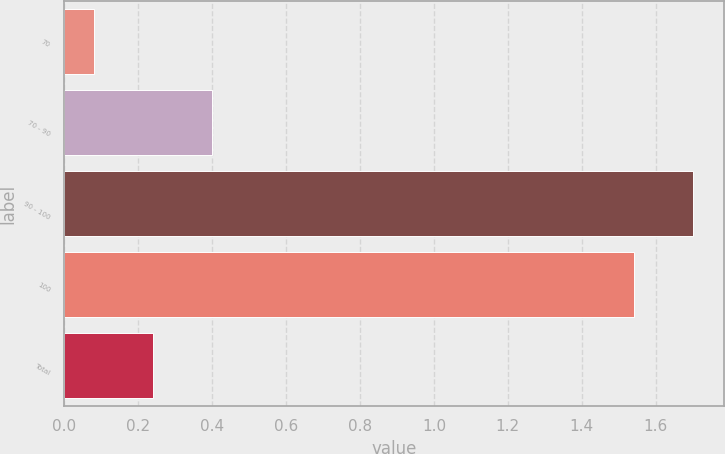<chart> <loc_0><loc_0><loc_500><loc_500><bar_chart><fcel>70<fcel>70 - 90<fcel>90 - 100<fcel>100<fcel>Total<nl><fcel>0.08<fcel>0.4<fcel>1.7<fcel>1.54<fcel>0.24<nl></chart> 